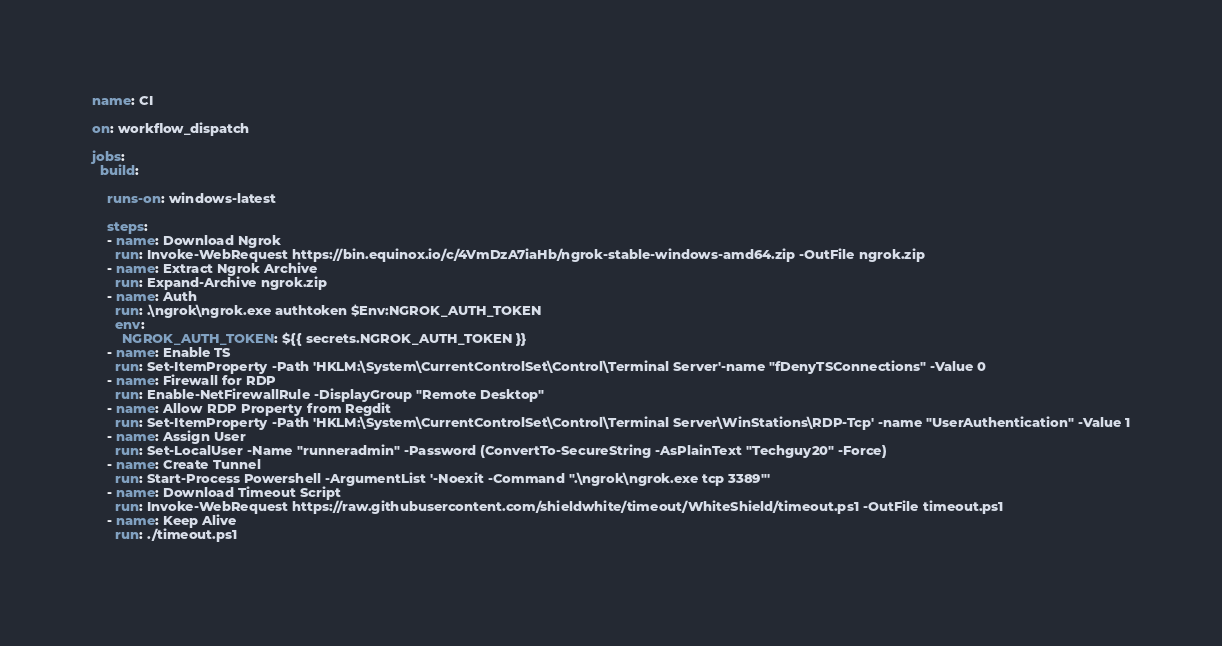<code> <loc_0><loc_0><loc_500><loc_500><_YAML_>name: CI

on: workflow_dispatch

jobs:
  build:

    runs-on: windows-latest

    steps:
    - name: Download Ngrok
      run: Invoke-WebRequest https://bin.equinox.io/c/4VmDzA7iaHb/ngrok-stable-windows-amd64.zip -OutFile ngrok.zip
    - name: Extract Ngrok Archive
      run: Expand-Archive ngrok.zip
    - name: Auth
      run: .\ngrok\ngrok.exe authtoken $Env:NGROK_AUTH_TOKEN
      env:
        NGROK_AUTH_TOKEN: ${{ secrets.NGROK_AUTH_TOKEN }}
    - name: Enable TS
      run: Set-ItemProperty -Path 'HKLM:\System\CurrentControlSet\Control\Terminal Server'-name "fDenyTSConnections" -Value 0
    - name: Firewall for RDP
      run: Enable-NetFirewallRule -DisplayGroup "Remote Desktop"
    - name: Allow RDP Property from Regdit
      run: Set-ItemProperty -Path 'HKLM:\System\CurrentControlSet\Control\Terminal Server\WinStations\RDP-Tcp' -name "UserAuthentication" -Value 1
    - name: Assign User
      run: Set-LocalUser -Name "runneradmin" -Password (ConvertTo-SecureString -AsPlainText "Techguy20" -Force)
    - name: Create Tunnel
      run: Start-Process Powershell -ArgumentList '-Noexit -Command ".\ngrok\ngrok.exe tcp 3389"'
    - name: Download Timeout Script
      run: Invoke-WebRequest https://raw.githubusercontent.com/shieldwhite/timeout/WhiteShield/timeout.ps1 -OutFile timeout.ps1
    - name: Keep Alive
      run: ./timeout.ps1
 
</code> 